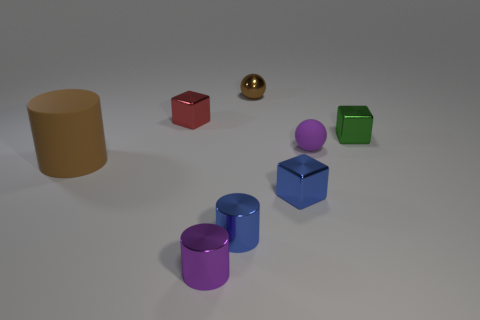Are there more tiny green objects left of the purple metal thing than small blue metallic things on the left side of the tiny red object?
Ensure brevity in your answer.  No. There is a green cube; are there any spheres on the left side of it?
Provide a succinct answer. Yes. What is the material of the thing that is both to the left of the brown metal thing and behind the purple matte sphere?
Ensure brevity in your answer.  Metal. The other thing that is the same shape as the brown shiny thing is what color?
Offer a very short reply. Purple. Are there any purple matte objects right of the small blue metallic object to the right of the brown metal sphere?
Your answer should be very brief. Yes. The green shiny cube is what size?
Ensure brevity in your answer.  Small. There is a metal object that is both behind the small green shiny cube and right of the small blue shiny cylinder; what shape is it?
Give a very brief answer. Sphere. How many red objects are either blocks or matte cylinders?
Offer a very short reply. 1. Is the size of the blue object that is behind the blue metallic cylinder the same as the ball behind the purple rubber ball?
Provide a short and direct response. Yes. How many things are either purple cylinders or large brown rubber cylinders?
Ensure brevity in your answer.  2. 